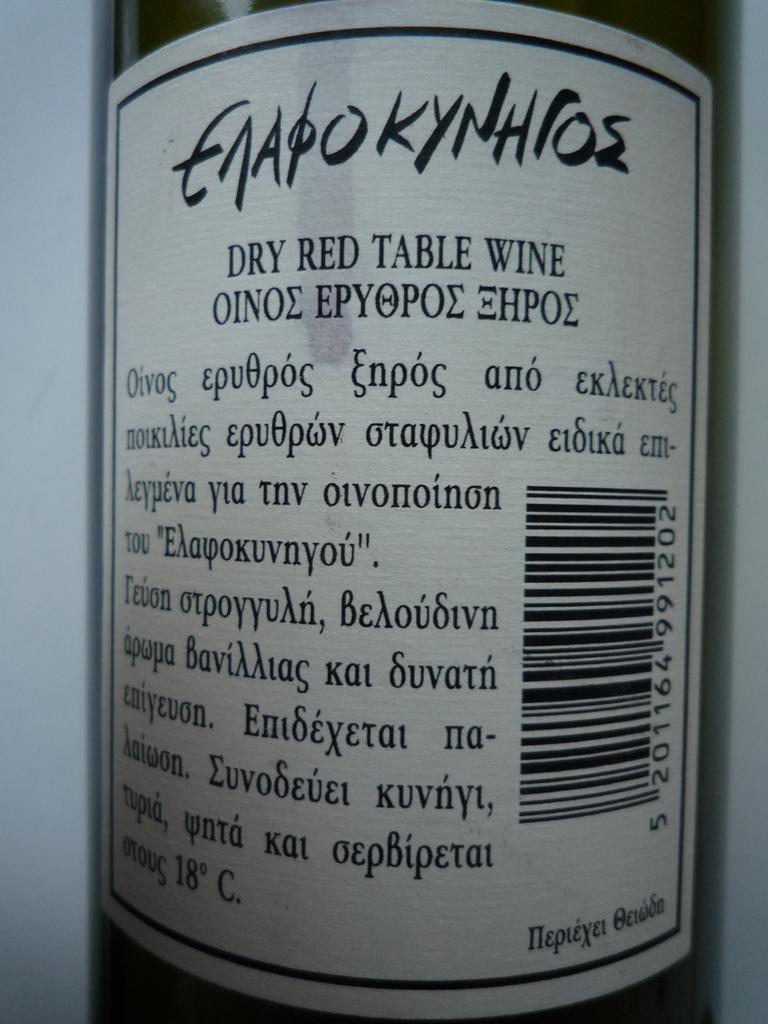What flavor of wine is this?
Offer a very short reply. Dry red. What is the last number of the bar code?
Your answer should be compact. 2. 